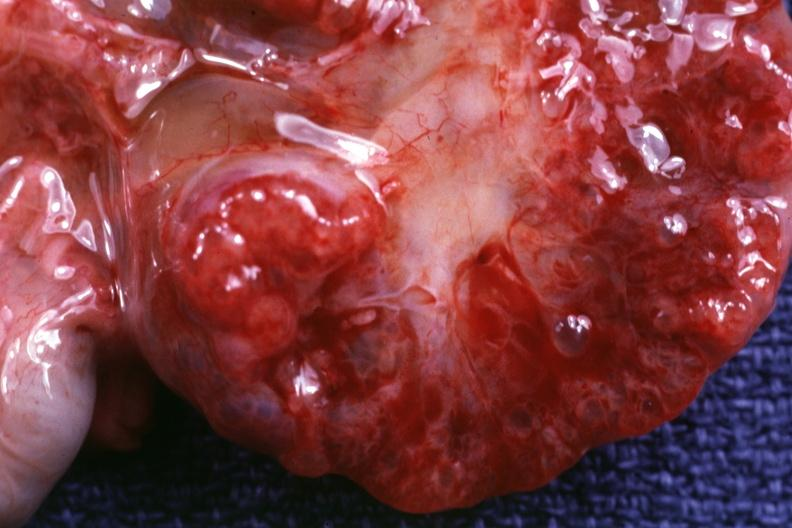s polycystic disease infant present?
Answer the question using a single word or phrase. Yes 